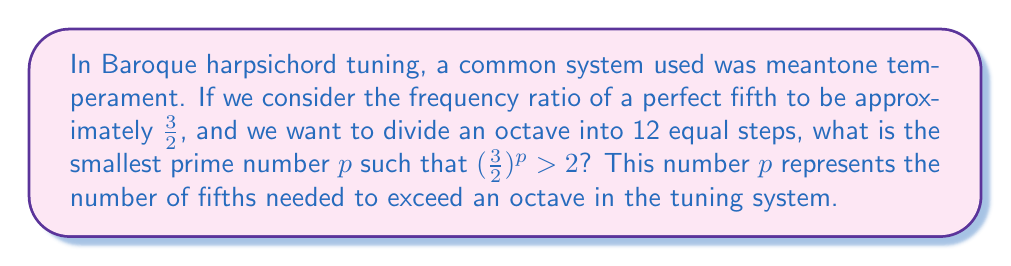Can you answer this question? Let's approach this step-by-step:

1) We need to find the smallest value of $p$ such that $(\frac{3}{2})^p > 2$.

2) We can rewrite this inequality as:
   $$(\frac{3}{2})^p > 2$$

3) Taking the logarithm of both sides:
   $$p \log(\frac{3}{2}) > \log(2)$$

4) Solving for $p$:
   $$p > \frac{\log(2)}{\log(\frac{3}{2})}$$

5) Using a calculator or computer, we can evaluate this:
   $$p > \frac{0.6931...}{0.4054...} \approx 1.7099...$$

6) Since $p$ must be a prime number, we need to find the smallest prime number greater than this value.

7) The first few prime numbers are 2, 3, 5, 7, 11, ...

8) Therefore, the smallest prime $p$ that satisfies the inequality is 2.

9) We can verify: $(\frac{3}{2})^2 = \frac{9}{4} = 2.25 > 2$

This result is significant in music theory and harpsichord tuning. In the Pythagorean tuning system, which was a precursor to meantone temperament often used in Baroque music, 12 perfect fifths exceed 7 octaves by a small amount known as the Pythagorean comma. This discrepancy led to the development of various temperaments to distribute the comma and make the instrument more harmonious across different keys.
Answer: 2 